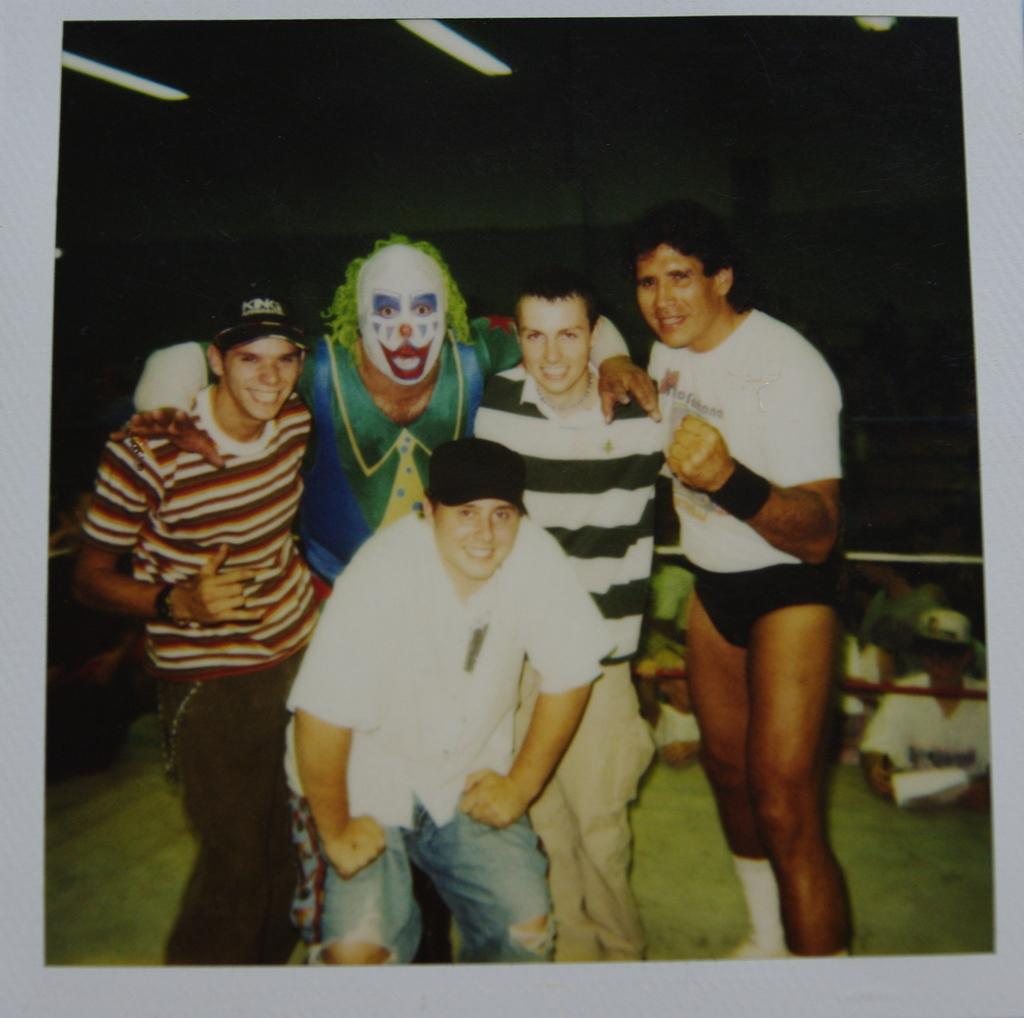What is depicted on the poster in the image? There is a poster with people in the image. What else can be seen in the image besides the poster? There are ropes visible in the image. What type of surface is visible at the bottom of the image? The ground is visible in the image. What part of a building can be seen at the top of the image? The roof is visible in the image. What type of cheese is being used to hold the poster on the wall in the image? There is no cheese present in the image, and the poster is not being held up by any cheese. 